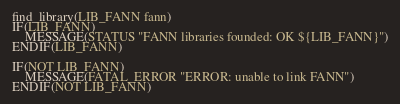Convert code to text. <code><loc_0><loc_0><loc_500><loc_500><_CMake_>find_library(LIB_FANN fann)
IF(LIB_FANN)
    MESSAGE(STATUS "FANN libraries founded: OK ${LIB_FANN}")
ENDIF(LIB_FANN)

IF(NOT LIB_FANN)
    MESSAGE(FATAL_ERROR "ERROR: unable to link FANN")
ENDIF(NOT LIB_FANN)</code> 